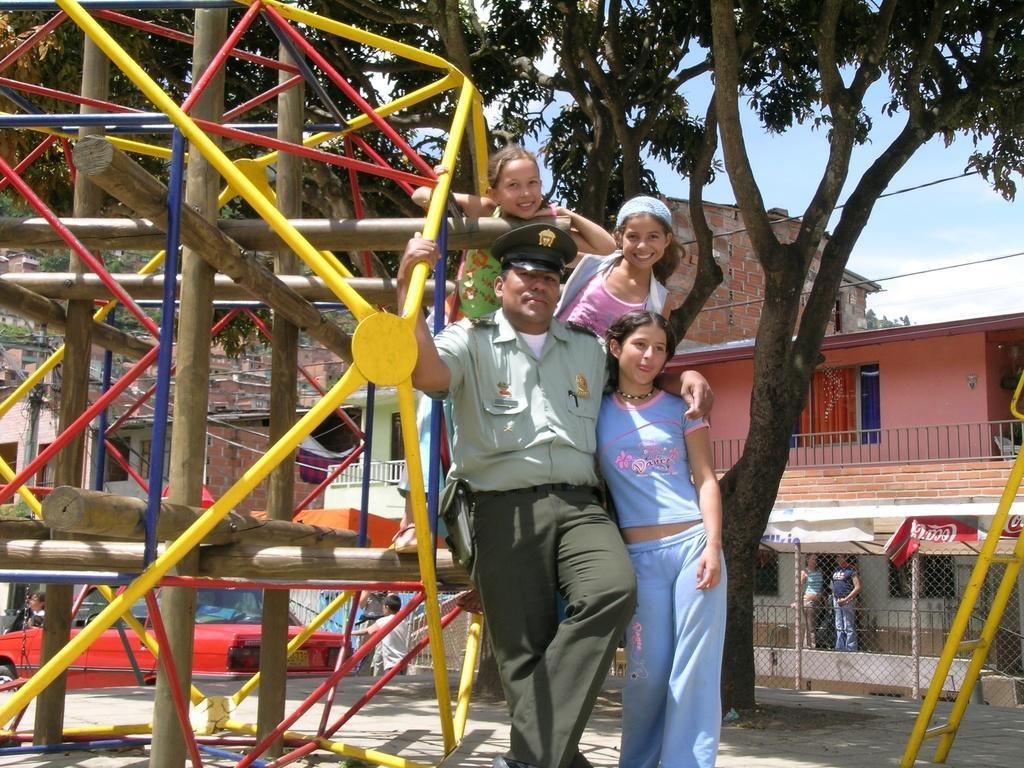In one or two sentences, can you explain what this image depicts? As we can see in the image there are trees, buildings, fence, few people standing in the front, an ironic equipment and on the top there is sky. 